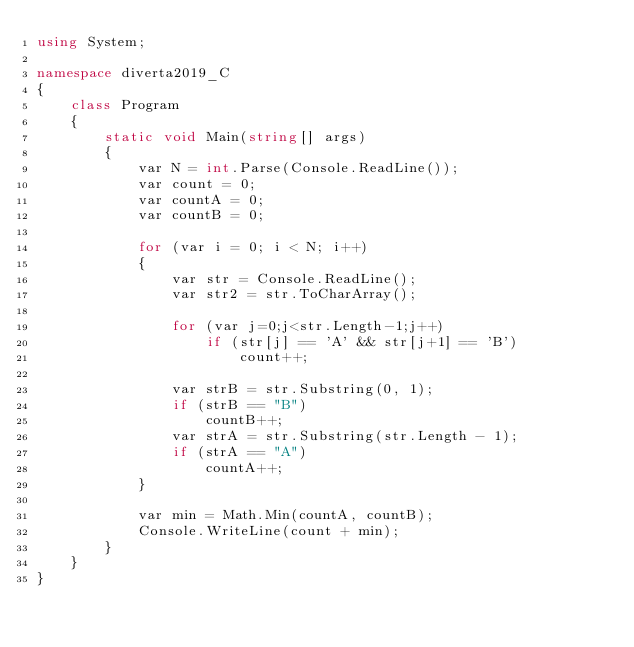<code> <loc_0><loc_0><loc_500><loc_500><_C#_>using System;

namespace diverta2019_C
{
    class Program
    {
        static void Main(string[] args)
        {
            var N = int.Parse(Console.ReadLine());
            var count = 0;
            var countA = 0;
            var countB = 0;

            for (var i = 0; i < N; i++)
            {
                var str = Console.ReadLine();
                var str2 = str.ToCharArray();

                for (var j=0;j<str.Length-1;j++)
                    if (str[j] == 'A' && str[j+1] == 'B')
                        count++;

                var strB = str.Substring(0, 1);
                if (strB == "B")
                    countB++;
                var strA = str.Substring(str.Length - 1);
                if (strA == "A")
                    countA++;
            }

            var min = Math.Min(countA, countB);
            Console.WriteLine(count + min);
        }
    }
}</code> 